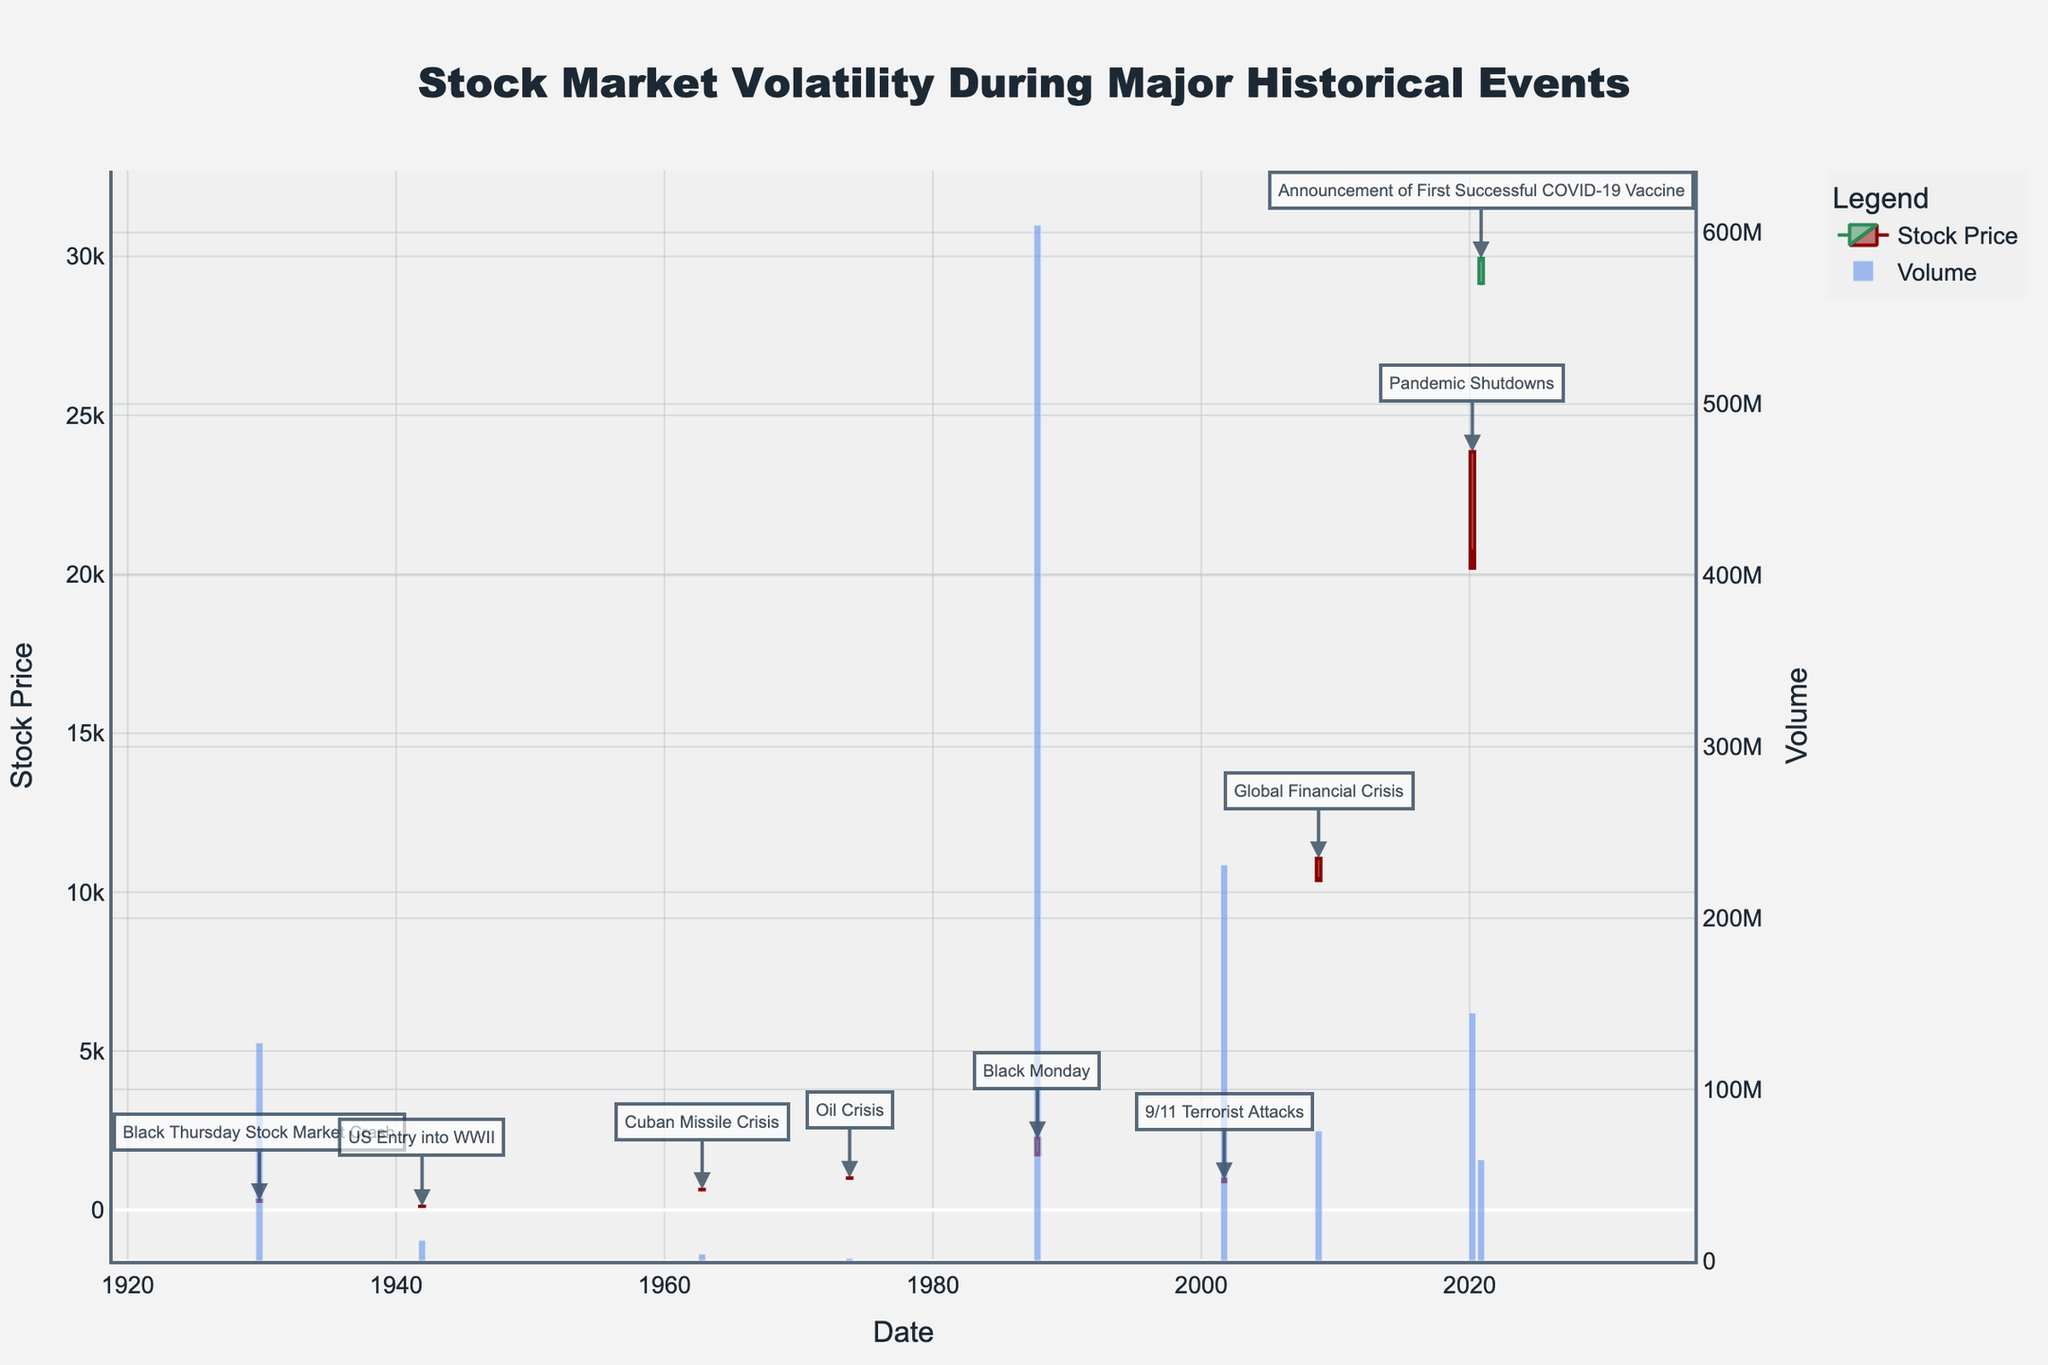What's the title of the plot? The title of the plot is located at the top and it provides a summary of the focus of the visual representation. The title is "Stock Market Volatility During Major Historical Events."
Answer: Stock Market Volatility During Major Historical Events What historical event corresponds to the highest trading volume on the plot? To find the event with the highest trading volume, check the highest bar in the volume bar chart and locate its corresponding date, then match this date with the historical event in the annotations. The highest volume occurs on 1987-10-19 during the Black Monday event.
Answer: Black Monday What general trend can be observed in the stock prices on the day of major crises? Analyzing the candlestick shapes and colors during the major crises from the annotations, it can be observed that most of them have red candlesticks with noticeable bearish trends, indicating drops in stock prices.
Answer: Bearish trend Which event shows the largest single-day drop in the stock price? Compare the difference between the opening and closing prices for each event. The largest single-day drop corresponds to the steepest candlestick, which occurred on 1987-10-19 (Black Monday) where the open price was 2246.73 and the close price was 1738.74, yielding a drop of 507.99 points.
Answer: Black Monday Compare the stock market reaction to the 9/11 Terrorist Attacks and the Global Financial Crisis. Which had a more significant drop in the closing price? To determine this, examine the closing prices of both events (2001-09-17 for 9/11 Terrorist Attacks and 2008-09-29 for Global Financial Crisis). The 9/11 attacks' closing price dropped to 892.06 from 960.25. The Global Financial Crisis had the closing price drop to 10365.45 from 11056.85. The absolute drop is larger for the 9/11 attacks as it dropped by 68.19 points, whereas the Global Financial Crisis dropped by 691.40 points.
Answer: Global Financial Crisis Are there any events during which the market ended higher on that day? Refer to the candlestick colors for each event to see which events end with a green candlestick (indicating a day that closed higher than it opened). The Announcement of First Successful COVID-19 Vaccine on 2020-11-09 shows a green candlestick where the closing price of 29933.83 is higher than the opening price of 29157.69.
Answer: Announcement of First Successful COVID-19 Vaccine Considering the Cuban Missile Crisis and the Oil Crisis, which had a lower range between the high and low prices of the day? Calculate the range (High - Low) for both events. For the Cuban Missile Crisis (1962-10-22), the range is 648.39 - 633.68 = 14.71. For the Oil Crisis (1973-10-19), the range is 1008.42 - 994.58 = 13.84. Therefore, the Oil Crisis had a slightly lower range.
Answer: Oil Crisis 